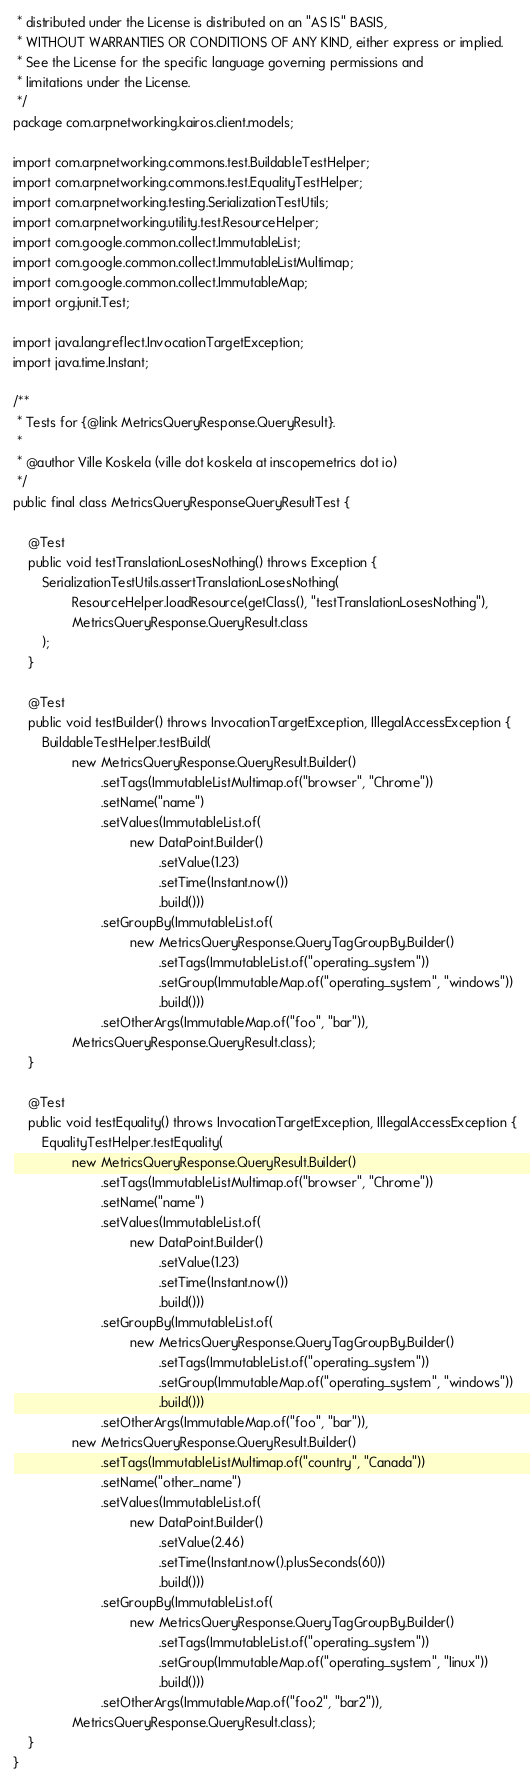<code> <loc_0><loc_0><loc_500><loc_500><_Java_> * distributed under the License is distributed on an "AS IS" BASIS,
 * WITHOUT WARRANTIES OR CONDITIONS OF ANY KIND, either express or implied.
 * See the License for the specific language governing permissions and
 * limitations under the License.
 */
package com.arpnetworking.kairos.client.models;

import com.arpnetworking.commons.test.BuildableTestHelper;
import com.arpnetworking.commons.test.EqualityTestHelper;
import com.arpnetworking.testing.SerializationTestUtils;
import com.arpnetworking.utility.test.ResourceHelper;
import com.google.common.collect.ImmutableList;
import com.google.common.collect.ImmutableListMultimap;
import com.google.common.collect.ImmutableMap;
import org.junit.Test;

import java.lang.reflect.InvocationTargetException;
import java.time.Instant;

/**
 * Tests for {@link MetricsQueryResponse.QueryResult}.
 *
 * @author Ville Koskela (ville dot koskela at inscopemetrics dot io)
 */
public final class MetricsQueryResponseQueryResultTest {

    @Test
    public void testTranslationLosesNothing() throws Exception {
        SerializationTestUtils.assertTranslationLosesNothing(
                ResourceHelper.loadResource(getClass(), "testTranslationLosesNothing"),
                MetricsQueryResponse.QueryResult.class
        );
    }

    @Test
    public void testBuilder() throws InvocationTargetException, IllegalAccessException {
        BuildableTestHelper.testBuild(
                new MetricsQueryResponse.QueryResult.Builder()
                        .setTags(ImmutableListMultimap.of("browser", "Chrome"))
                        .setName("name")
                        .setValues(ImmutableList.of(
                                new DataPoint.Builder()
                                        .setValue(1.23)
                                        .setTime(Instant.now())
                                        .build()))
                        .setGroupBy(ImmutableList.of(
                                new MetricsQueryResponse.QueryTagGroupBy.Builder()
                                        .setTags(ImmutableList.of("operating_system"))
                                        .setGroup(ImmutableMap.of("operating_system", "windows"))
                                        .build()))
                        .setOtherArgs(ImmutableMap.of("foo", "bar")),
                MetricsQueryResponse.QueryResult.class);
    }

    @Test
    public void testEquality() throws InvocationTargetException, IllegalAccessException {
        EqualityTestHelper.testEquality(
                new MetricsQueryResponse.QueryResult.Builder()
                        .setTags(ImmutableListMultimap.of("browser", "Chrome"))
                        .setName("name")
                        .setValues(ImmutableList.of(
                                new DataPoint.Builder()
                                        .setValue(1.23)
                                        .setTime(Instant.now())
                                        .build()))
                        .setGroupBy(ImmutableList.of(
                                new MetricsQueryResponse.QueryTagGroupBy.Builder()
                                        .setTags(ImmutableList.of("operating_system"))
                                        .setGroup(ImmutableMap.of("operating_system", "windows"))
                                        .build()))
                        .setOtherArgs(ImmutableMap.of("foo", "bar")),
                new MetricsQueryResponse.QueryResult.Builder()
                        .setTags(ImmutableListMultimap.of("country", "Canada"))
                        .setName("other_name")
                        .setValues(ImmutableList.of(
                                new DataPoint.Builder()
                                        .setValue(2.46)
                                        .setTime(Instant.now().plusSeconds(60))
                                        .build()))
                        .setGroupBy(ImmutableList.of(
                                new MetricsQueryResponse.QueryTagGroupBy.Builder()
                                        .setTags(ImmutableList.of("operating_system"))
                                        .setGroup(ImmutableMap.of("operating_system", "linux"))
                                        .build()))
                        .setOtherArgs(ImmutableMap.of("foo2", "bar2")),
                MetricsQueryResponse.QueryResult.class);
    }
}
</code> 